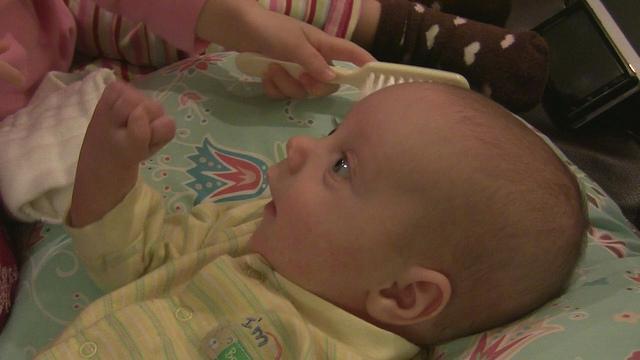How many people are visible?
Give a very brief answer. 2. 